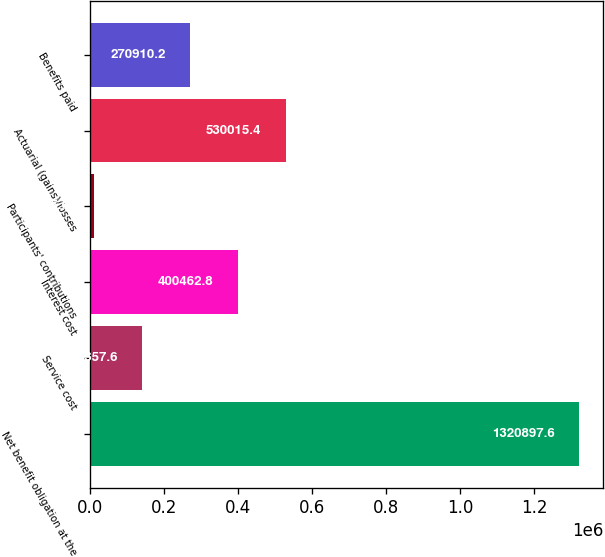Convert chart. <chart><loc_0><loc_0><loc_500><loc_500><bar_chart><fcel>Net benefit obligation at the<fcel>Service cost<fcel>Interest cost<fcel>Participants' contributions<fcel>Actuarial (gains)/losses<fcel>Benefits paid<nl><fcel>1.3209e+06<fcel>141358<fcel>400463<fcel>11805<fcel>530015<fcel>270910<nl></chart> 